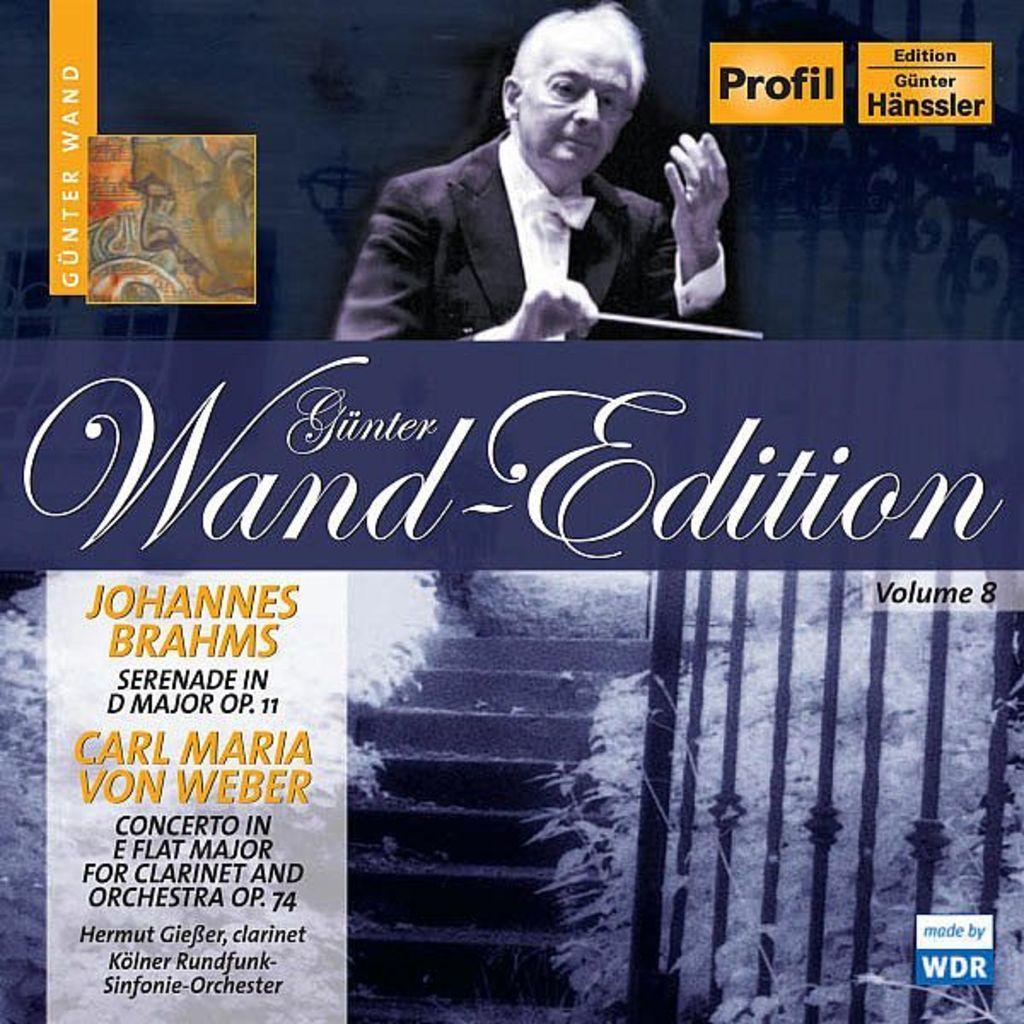Please provide a concise description of this image. In the image it looks like some cover page of a magazine, there are some statements and other texts on the page and there is also a photo of a person. 